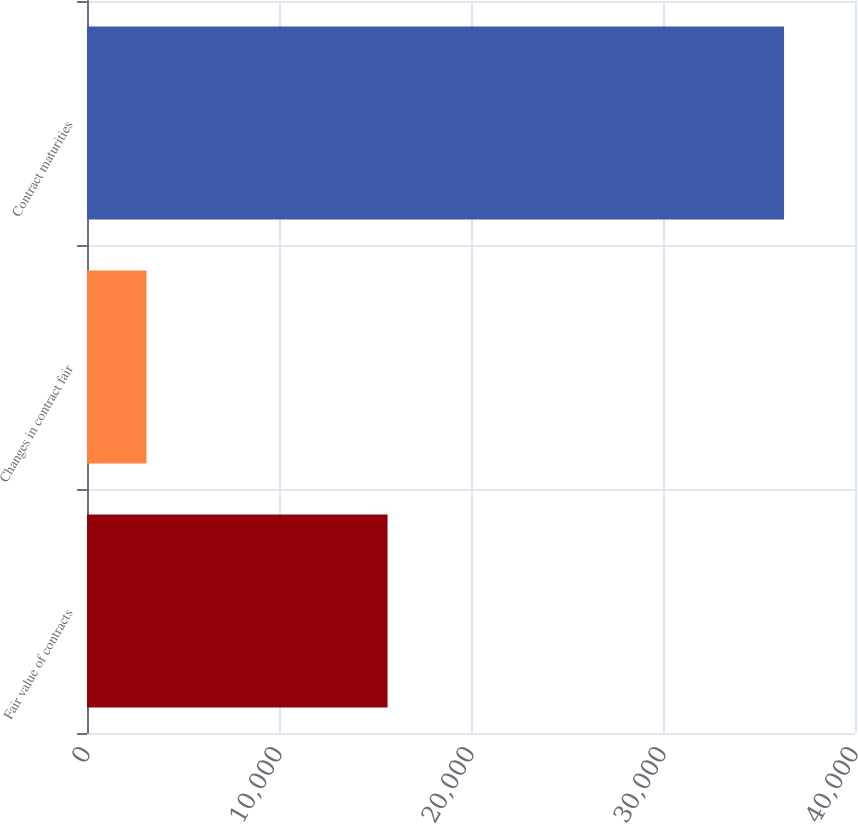Convert chart to OTSL. <chart><loc_0><loc_0><loc_500><loc_500><bar_chart><fcel>Fair value of contracts<fcel>Changes in contract fair<fcel>Contract maturities<nl><fcel>15654<fcel>3098<fcel>36304<nl></chart> 